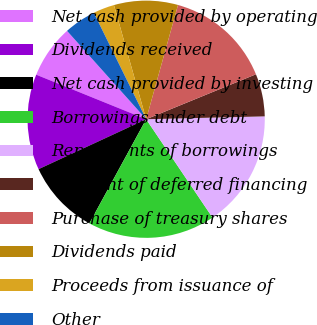Convert chart to OTSL. <chart><loc_0><loc_0><loc_500><loc_500><pie_chart><fcel>Net cash provided by operating<fcel>Dividends received<fcel>Net cash provided by investing<fcel>Borrowings under debt<fcel>Repayments of borrowings<fcel>Payment of deferred financing<fcel>Purchase of treasury shares<fcel>Dividends paid<fcel>Proceeds from issuance of<fcel>Other<nl><fcel>7.25%<fcel>13.04%<fcel>10.14%<fcel>17.39%<fcel>15.94%<fcel>5.8%<fcel>14.49%<fcel>8.7%<fcel>2.9%<fcel>4.35%<nl></chart> 